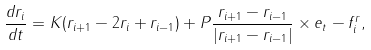<formula> <loc_0><loc_0><loc_500><loc_500>\frac { d { r } _ { i } } { d t } = K ( { r } _ { i + 1 } - 2 { r } _ { i } + { r } _ { i - 1 } ) + P \frac { { r } _ { i + 1 } - { r } _ { i - 1 } } { | { r } _ { i + 1 } - { r } _ { i - 1 } | } \times { e } _ { t } - { f } _ { i } ^ { r } ,</formula> 